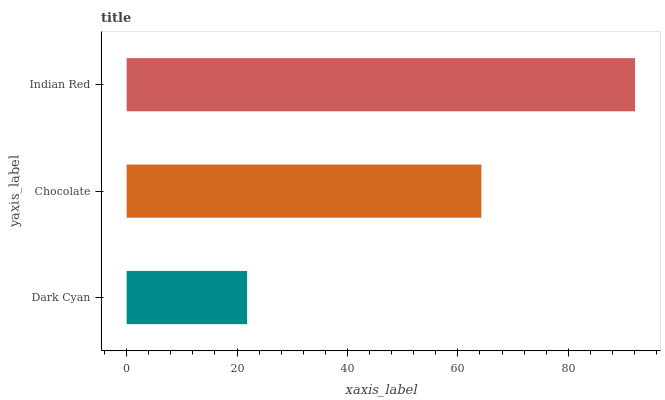Is Dark Cyan the minimum?
Answer yes or no. Yes. Is Indian Red the maximum?
Answer yes or no. Yes. Is Chocolate the minimum?
Answer yes or no. No. Is Chocolate the maximum?
Answer yes or no. No. Is Chocolate greater than Dark Cyan?
Answer yes or no. Yes. Is Dark Cyan less than Chocolate?
Answer yes or no. Yes. Is Dark Cyan greater than Chocolate?
Answer yes or no. No. Is Chocolate less than Dark Cyan?
Answer yes or no. No. Is Chocolate the high median?
Answer yes or no. Yes. Is Chocolate the low median?
Answer yes or no. Yes. Is Indian Red the high median?
Answer yes or no. No. Is Dark Cyan the low median?
Answer yes or no. No. 